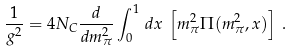Convert formula to latex. <formula><loc_0><loc_0><loc_500><loc_500>\frac { 1 } { g ^ { 2 } } = 4 N _ { C } \frac { d } { d m _ { \pi } ^ { 2 } } \int _ { 0 } ^ { 1 } \, d x \, \left [ m ^ { 2 } _ { \pi } \Pi ( m _ { \pi } ^ { 2 } , x ) \right ] \, .</formula> 